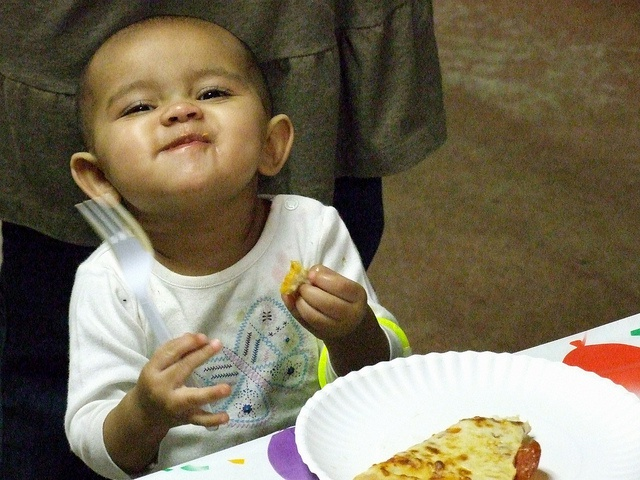Describe the objects in this image and their specific colors. I can see people in black, lightgray, olive, darkgray, and tan tones, people in black, darkgreen, and gray tones, dining table in black, white, khaki, and red tones, pizza in black, khaki, brown, and ivory tones, and fork in black, lightgray, darkgray, and gray tones in this image. 